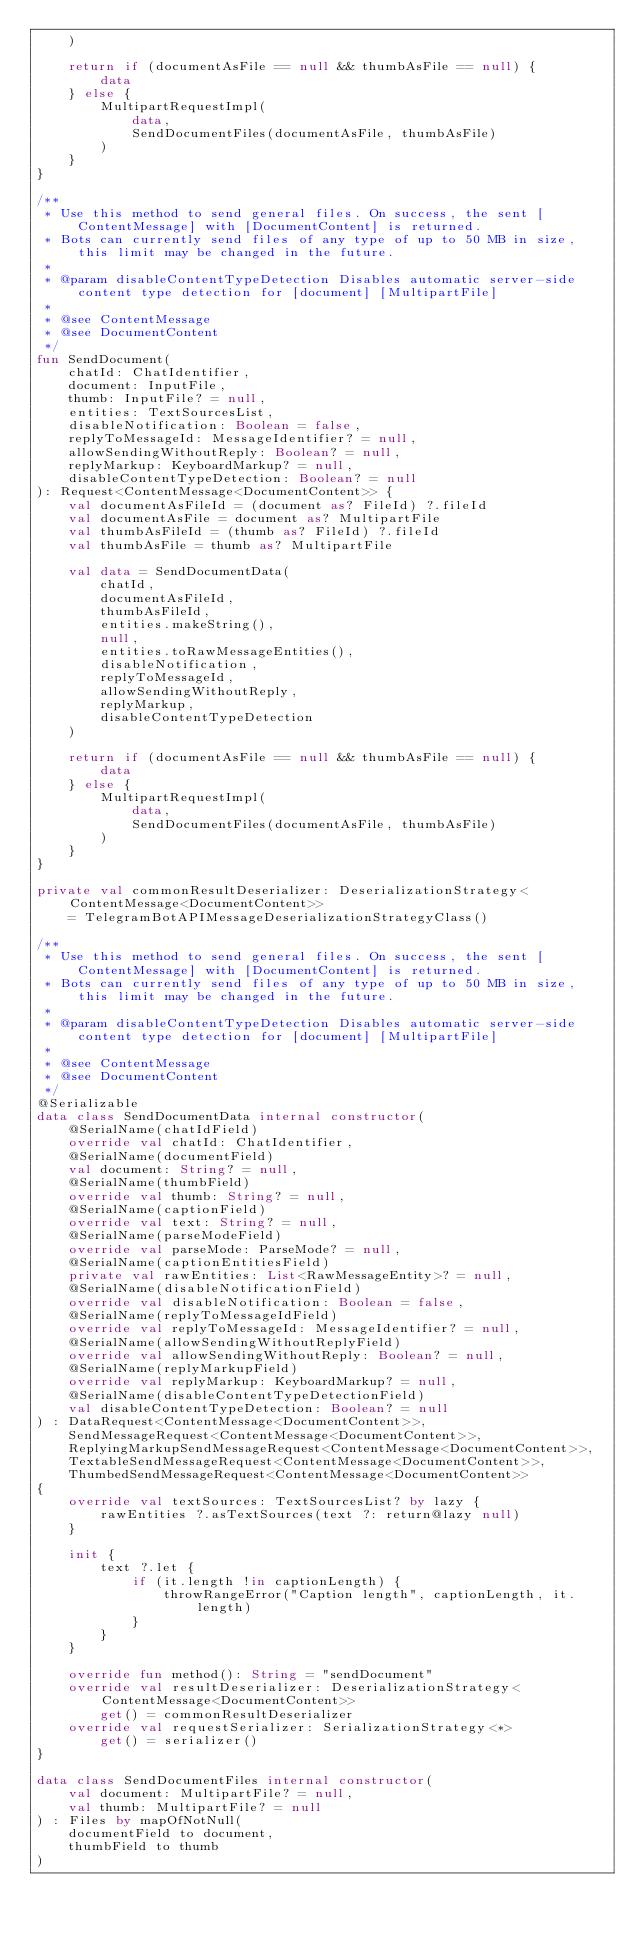Convert code to text. <code><loc_0><loc_0><loc_500><loc_500><_Kotlin_>    )

    return if (documentAsFile == null && thumbAsFile == null) {
        data
    } else {
        MultipartRequestImpl(
            data,
            SendDocumentFiles(documentAsFile, thumbAsFile)
        )
    }
}

/**
 * Use this method to send general files. On success, the sent [ContentMessage] with [DocumentContent] is returned.
 * Bots can currently send files of any type of up to 50 MB in size, this limit may be changed in the future.
 *
 * @param disableContentTypeDetection Disables automatic server-side content type detection for [document] [MultipartFile]
 *
 * @see ContentMessage
 * @see DocumentContent
 */
fun SendDocument(
    chatId: ChatIdentifier,
    document: InputFile,
    thumb: InputFile? = null,
    entities: TextSourcesList,
    disableNotification: Boolean = false,
    replyToMessageId: MessageIdentifier? = null,
    allowSendingWithoutReply: Boolean? = null,
    replyMarkup: KeyboardMarkup? = null,
    disableContentTypeDetection: Boolean? = null
): Request<ContentMessage<DocumentContent>> {
    val documentAsFileId = (document as? FileId) ?.fileId
    val documentAsFile = document as? MultipartFile
    val thumbAsFileId = (thumb as? FileId) ?.fileId
    val thumbAsFile = thumb as? MultipartFile

    val data = SendDocumentData(
        chatId,
        documentAsFileId,
        thumbAsFileId,
        entities.makeString(),
        null,
        entities.toRawMessageEntities(),
        disableNotification,
        replyToMessageId,
        allowSendingWithoutReply,
        replyMarkup,
        disableContentTypeDetection
    )

    return if (documentAsFile == null && thumbAsFile == null) {
        data
    } else {
        MultipartRequestImpl(
            data,
            SendDocumentFiles(documentAsFile, thumbAsFile)
        )
    }
}

private val commonResultDeserializer: DeserializationStrategy<ContentMessage<DocumentContent>>
    = TelegramBotAPIMessageDeserializationStrategyClass()

/**
 * Use this method to send general files. On success, the sent [ContentMessage] with [DocumentContent] is returned.
 * Bots can currently send files of any type of up to 50 MB in size, this limit may be changed in the future.
 *
 * @param disableContentTypeDetection Disables automatic server-side content type detection for [document] [MultipartFile]
 *
 * @see ContentMessage
 * @see DocumentContent
 */
@Serializable
data class SendDocumentData internal constructor(
    @SerialName(chatIdField)
    override val chatId: ChatIdentifier,
    @SerialName(documentField)
    val document: String? = null,
    @SerialName(thumbField)
    override val thumb: String? = null,
    @SerialName(captionField)
    override val text: String? = null,
    @SerialName(parseModeField)
    override val parseMode: ParseMode? = null,
    @SerialName(captionEntitiesField)
    private val rawEntities: List<RawMessageEntity>? = null,
    @SerialName(disableNotificationField)
    override val disableNotification: Boolean = false,
    @SerialName(replyToMessageIdField)
    override val replyToMessageId: MessageIdentifier? = null,
    @SerialName(allowSendingWithoutReplyField)
    override val allowSendingWithoutReply: Boolean? = null,
    @SerialName(replyMarkupField)
    override val replyMarkup: KeyboardMarkup? = null,
    @SerialName(disableContentTypeDetectionField)
    val disableContentTypeDetection: Boolean? = null
) : DataRequest<ContentMessage<DocumentContent>>,
    SendMessageRequest<ContentMessage<DocumentContent>>,
    ReplyingMarkupSendMessageRequest<ContentMessage<DocumentContent>>,
    TextableSendMessageRequest<ContentMessage<DocumentContent>>,
    ThumbedSendMessageRequest<ContentMessage<DocumentContent>>
{
    override val textSources: TextSourcesList? by lazy {
        rawEntities ?.asTextSources(text ?: return@lazy null)
    }

    init {
        text ?.let {
            if (it.length !in captionLength) {
                throwRangeError("Caption length", captionLength, it.length)
            }
        }
    }

    override fun method(): String = "sendDocument"
    override val resultDeserializer: DeserializationStrategy<ContentMessage<DocumentContent>>
        get() = commonResultDeserializer
    override val requestSerializer: SerializationStrategy<*>
        get() = serializer()
}

data class SendDocumentFiles internal constructor(
    val document: MultipartFile? = null,
    val thumb: MultipartFile? = null
) : Files by mapOfNotNull(
    documentField to document,
    thumbField to thumb
)
</code> 